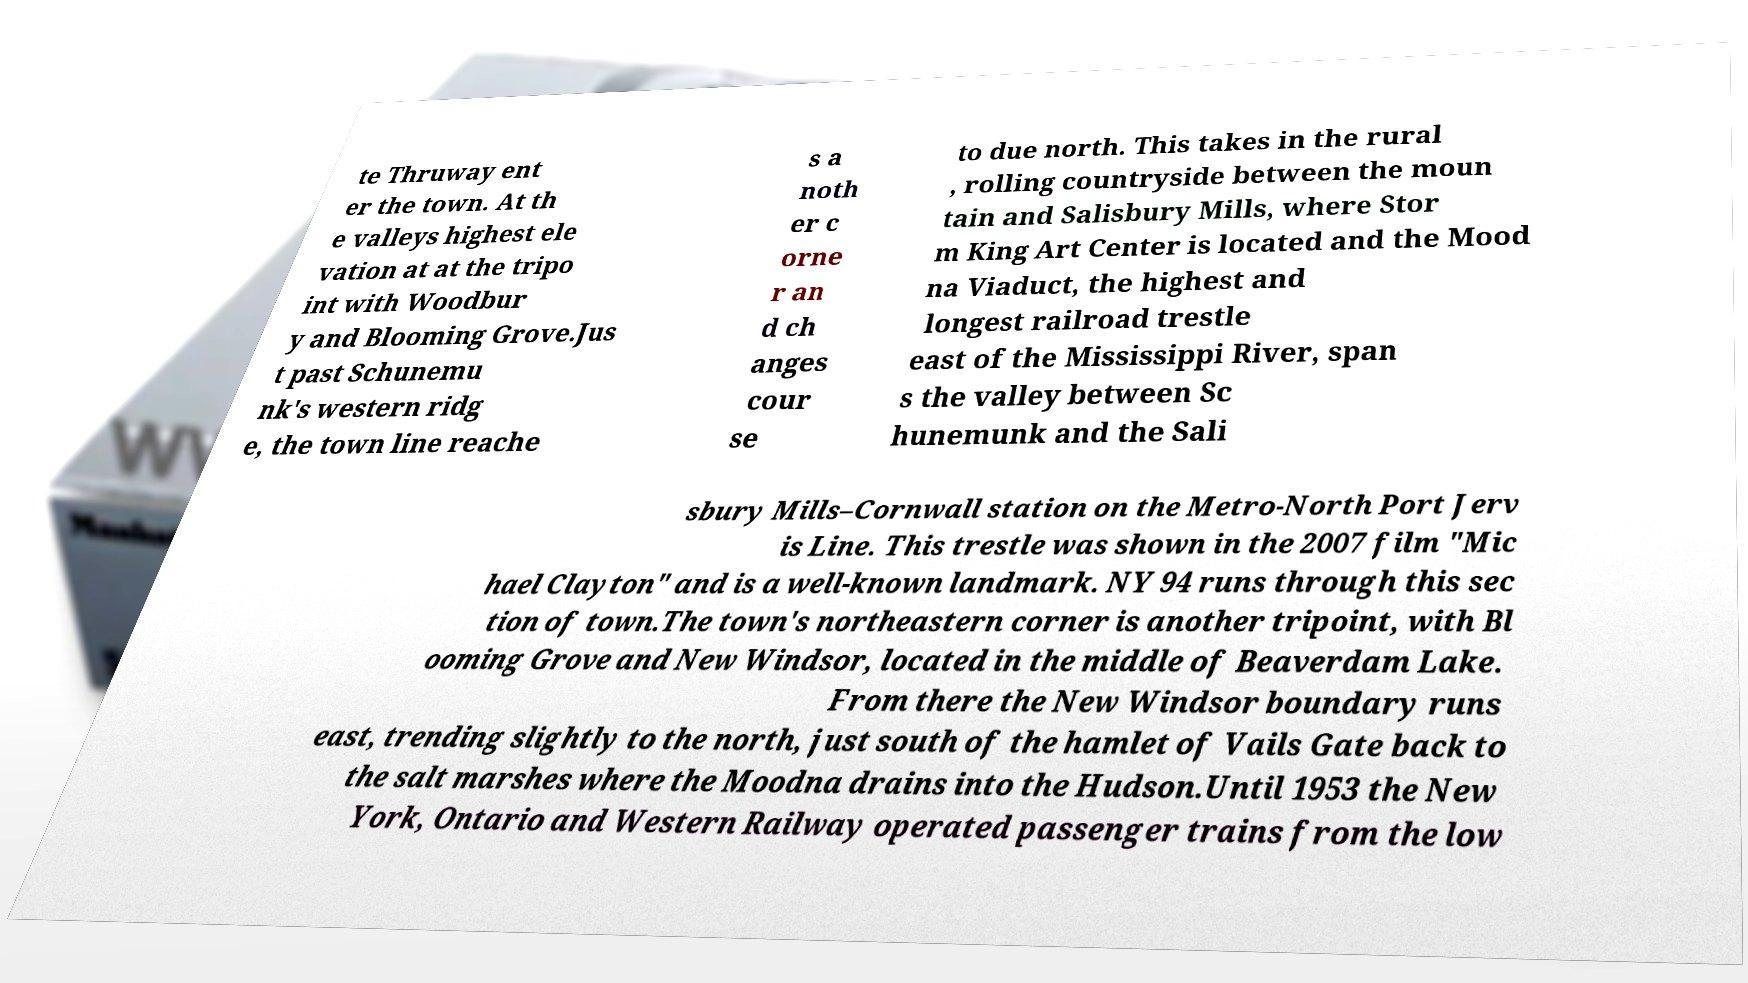Please read and relay the text visible in this image. What does it say? te Thruway ent er the town. At th e valleys highest ele vation at at the tripo int with Woodbur y and Blooming Grove.Jus t past Schunemu nk's western ridg e, the town line reache s a noth er c orne r an d ch anges cour se to due north. This takes in the rural , rolling countryside between the moun tain and Salisbury Mills, where Stor m King Art Center is located and the Mood na Viaduct, the highest and longest railroad trestle east of the Mississippi River, span s the valley between Sc hunemunk and the Sali sbury Mills–Cornwall station on the Metro-North Port Jerv is Line. This trestle was shown in the 2007 film "Mic hael Clayton" and is a well-known landmark. NY 94 runs through this sec tion of town.The town's northeastern corner is another tripoint, with Bl ooming Grove and New Windsor, located in the middle of Beaverdam Lake. From there the New Windsor boundary runs east, trending slightly to the north, just south of the hamlet of Vails Gate back to the salt marshes where the Moodna drains into the Hudson.Until 1953 the New York, Ontario and Western Railway operated passenger trains from the low 